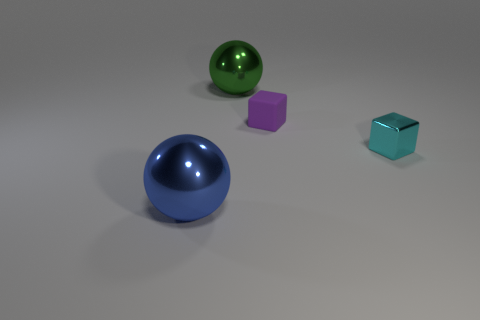Is there any other thing that has the same material as the tiny purple cube?
Your answer should be very brief. No. Is there any other thing that has the same color as the small matte block?
Offer a terse response. No. There is a large ball behind the small cube in front of the rubber object; what is its color?
Make the answer very short. Green. There is a big thing on the left side of the large object behind the big metallic thing in front of the metal block; what is it made of?
Give a very brief answer. Metal. How many blue shiny objects are the same size as the green sphere?
Give a very brief answer. 1. There is a thing that is on the left side of the small purple rubber object and in front of the green metal object; what material is it?
Make the answer very short. Metal. How many big metal spheres are in front of the rubber block?
Make the answer very short. 1. There is a cyan metal thing; is its shape the same as the small thing that is left of the tiny cyan cube?
Ensure brevity in your answer.  Yes. Are there any big blue things of the same shape as the tiny cyan metal thing?
Your answer should be very brief. No. What is the shape of the metal thing that is to the right of the big metal object to the right of the blue metal sphere?
Give a very brief answer. Cube. 